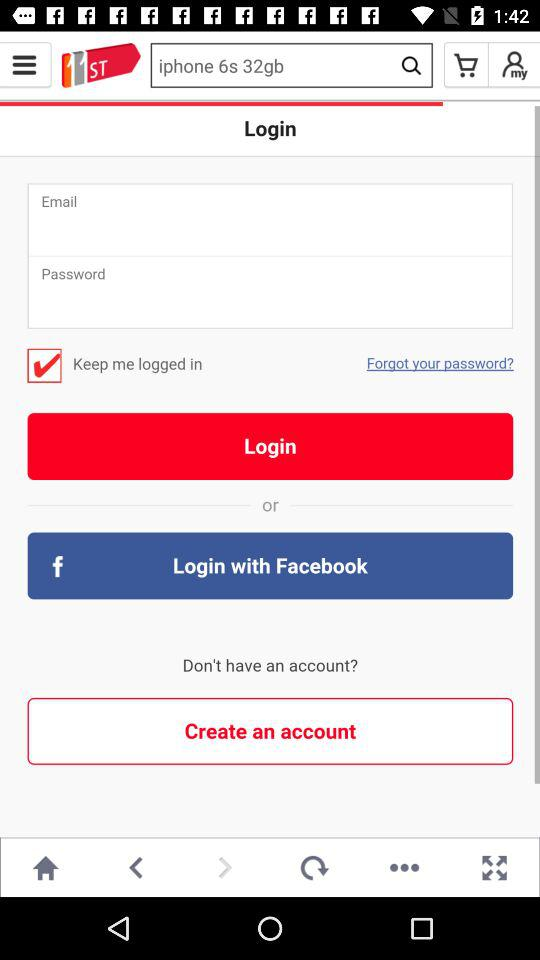What's the current slide number? The current slide number is 5. 